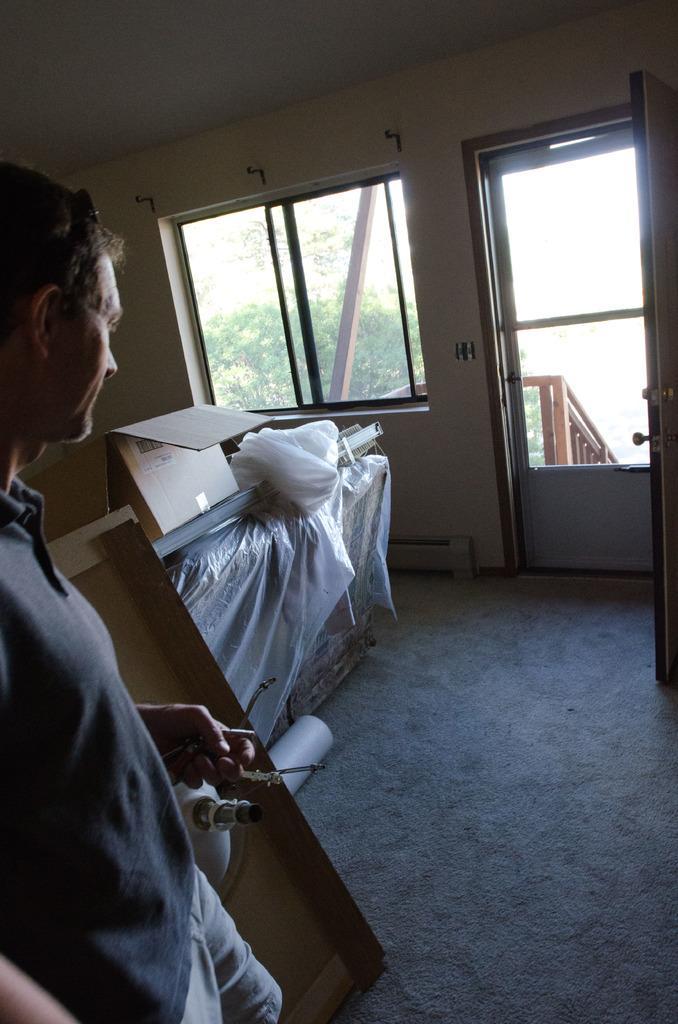Could you give a brief overview of what you see in this image? There is a man standing and holding an object. We can see cardboard box,cover and objects on the floor. We can see wall,glass window and door,through this glass window we can see trees. 